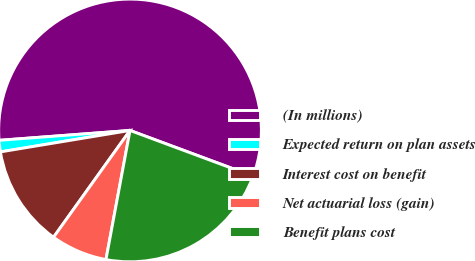Convert chart. <chart><loc_0><loc_0><loc_500><loc_500><pie_chart><fcel>(In millions)<fcel>Expected return on plan assets<fcel>Interest cost on benefit<fcel>Net actuarial loss (gain)<fcel>Benefit plans cost<nl><fcel>56.86%<fcel>1.41%<fcel>12.5%<fcel>6.96%<fcel>22.27%<nl></chart> 